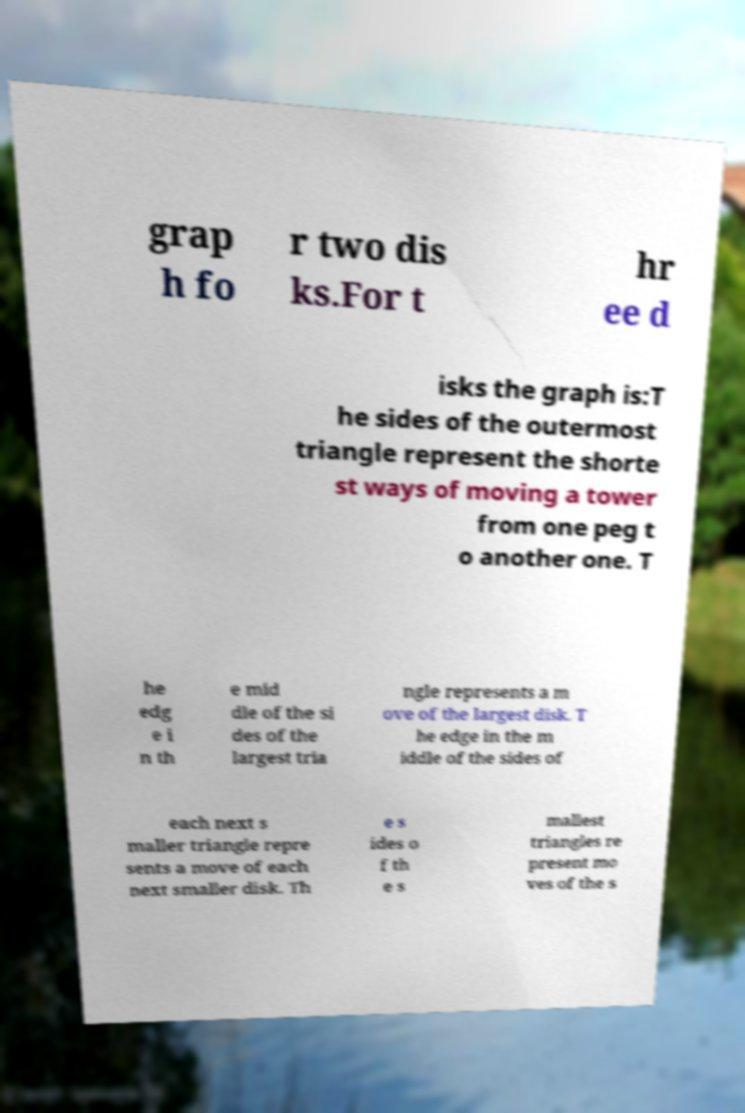Could you assist in decoding the text presented in this image and type it out clearly? grap h fo r two dis ks.For t hr ee d isks the graph is:T he sides of the outermost triangle represent the shorte st ways of moving a tower from one peg t o another one. T he edg e i n th e mid dle of the si des of the largest tria ngle represents a m ove of the largest disk. T he edge in the m iddle of the sides of each next s maller triangle repre sents a move of each next smaller disk. Th e s ides o f th e s mallest triangles re present mo ves of the s 